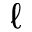<formula> <loc_0><loc_0><loc_500><loc_500>\ell</formula> 